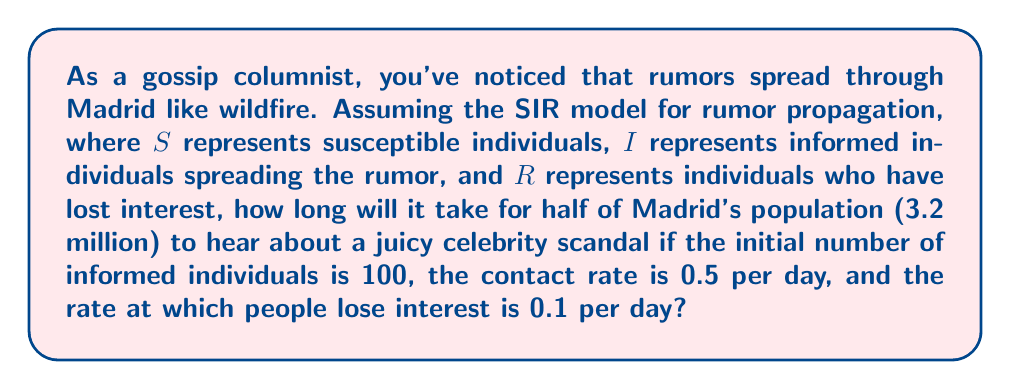Help me with this question. To solve this problem, we'll use the SIR model adapted for rumor spreading:

1. Set up the differential equations:
   $$\frac{dS}{dt} = -\beta SI$$
   $$\frac{dI}{dt} = \beta SI - \gamma I$$
   $$\frac{dR}{dt} = \gamma I$$

   Where:
   $\beta$ = contact rate = 0.5 per day
   $\gamma$ = rate of losing interest = 0.1 per day

2. We need to find when $S + I + R = 1.6$ million (half of 3.2 million).

3. The basic reproduction number $R_0 = \frac{\beta}{\gamma} = \frac{0.5}{0.1} = 5$

4. In the early stages, we can approximate the growth of I with:
   $$I(t) \approx I_0 e^{(\beta S_0 - \gamma)t}$$

   Where $I_0 = 100$ and $S_0 \approx 3.2$ million

5. Solving for t when $I(t) = 1.6$ million:
   $$1,600,000 = 100 e^{(0.5 \cdot 3,200,000 - 0.1)t}$$

6. Taking natural log of both sides:
   $$\ln(16,000) = (0.5 \cdot 3,200,000 - 0.1)t$$

7. Solving for t:
   $$t = \frac{\ln(16,000)}{0.5 \cdot 3,200,000 - 0.1} \approx 0.000018$$

8. Convert to hours:
   $$0.000018 \cdot 24 \approx 0.00043 \text{ hours}$$

9. Convert to minutes:
   $$0.00043 \cdot 60 \approx 0.026 \text{ minutes}$$

10. Convert to seconds:
    $$0.026 \cdot 60 \approx 1.56 \text{ seconds}$$
Answer: Approximately 1.56 seconds 